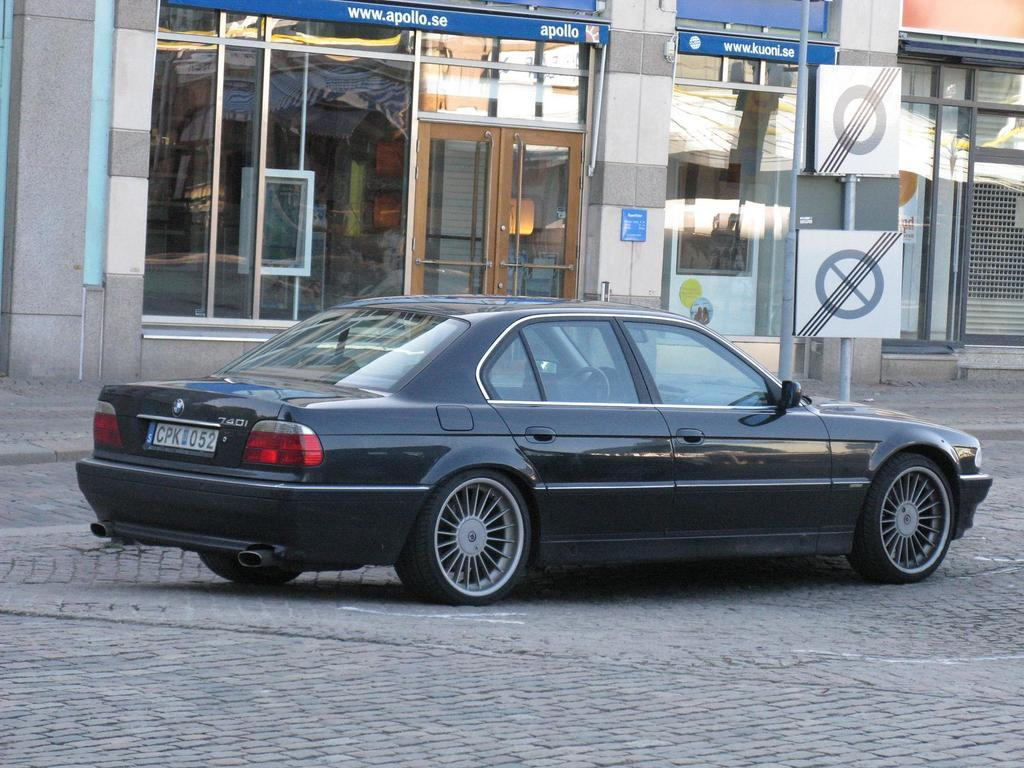What is the main subject of the image? There is a car on the road in the image. What can be seen in the background of the image? There are buildings, boards, and poles in the background of the image. What type of toothpaste is being advertised on the boards in the image? There is no toothpaste or advertisement visible on the boards in the image. Can you tell me how many people are resting in the car in the image? There is no indication of people resting in the car in the image. 